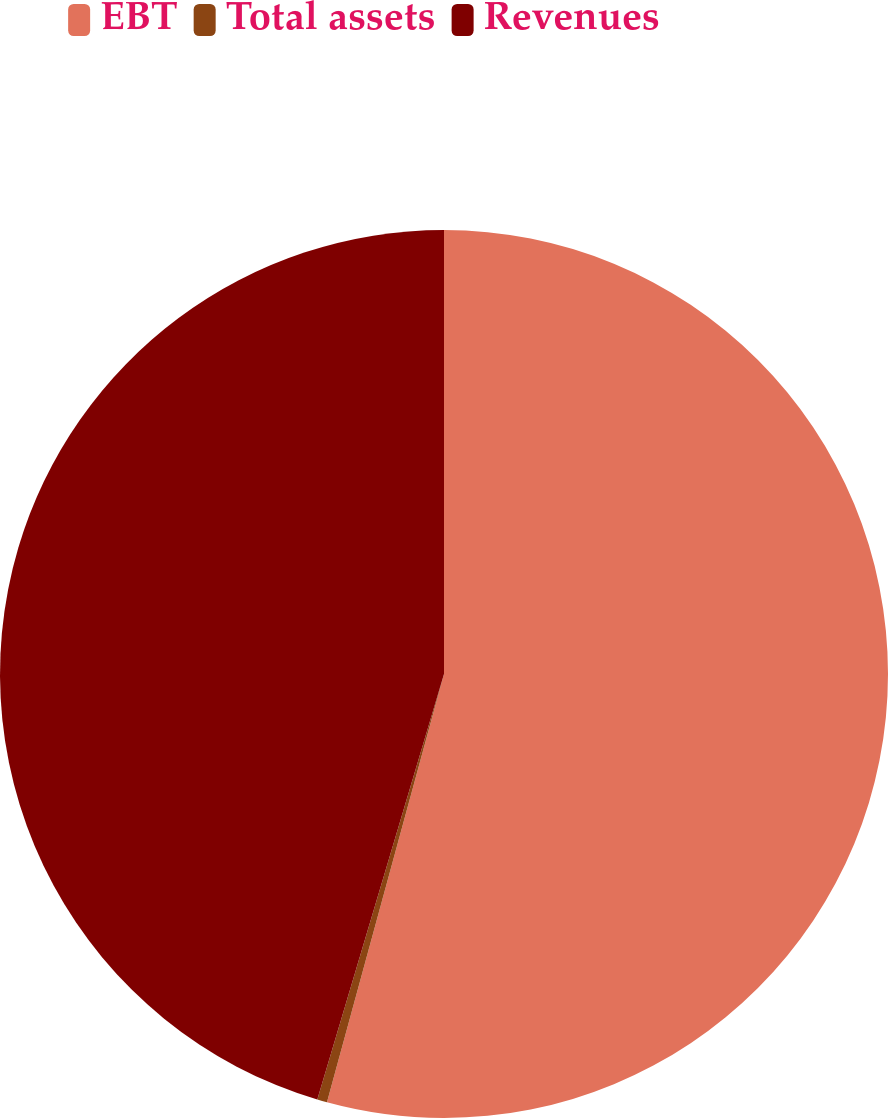Convert chart to OTSL. <chart><loc_0><loc_0><loc_500><loc_500><pie_chart><fcel>EBT<fcel>Total assets<fcel>Revenues<nl><fcel>54.24%<fcel>0.36%<fcel>45.39%<nl></chart> 